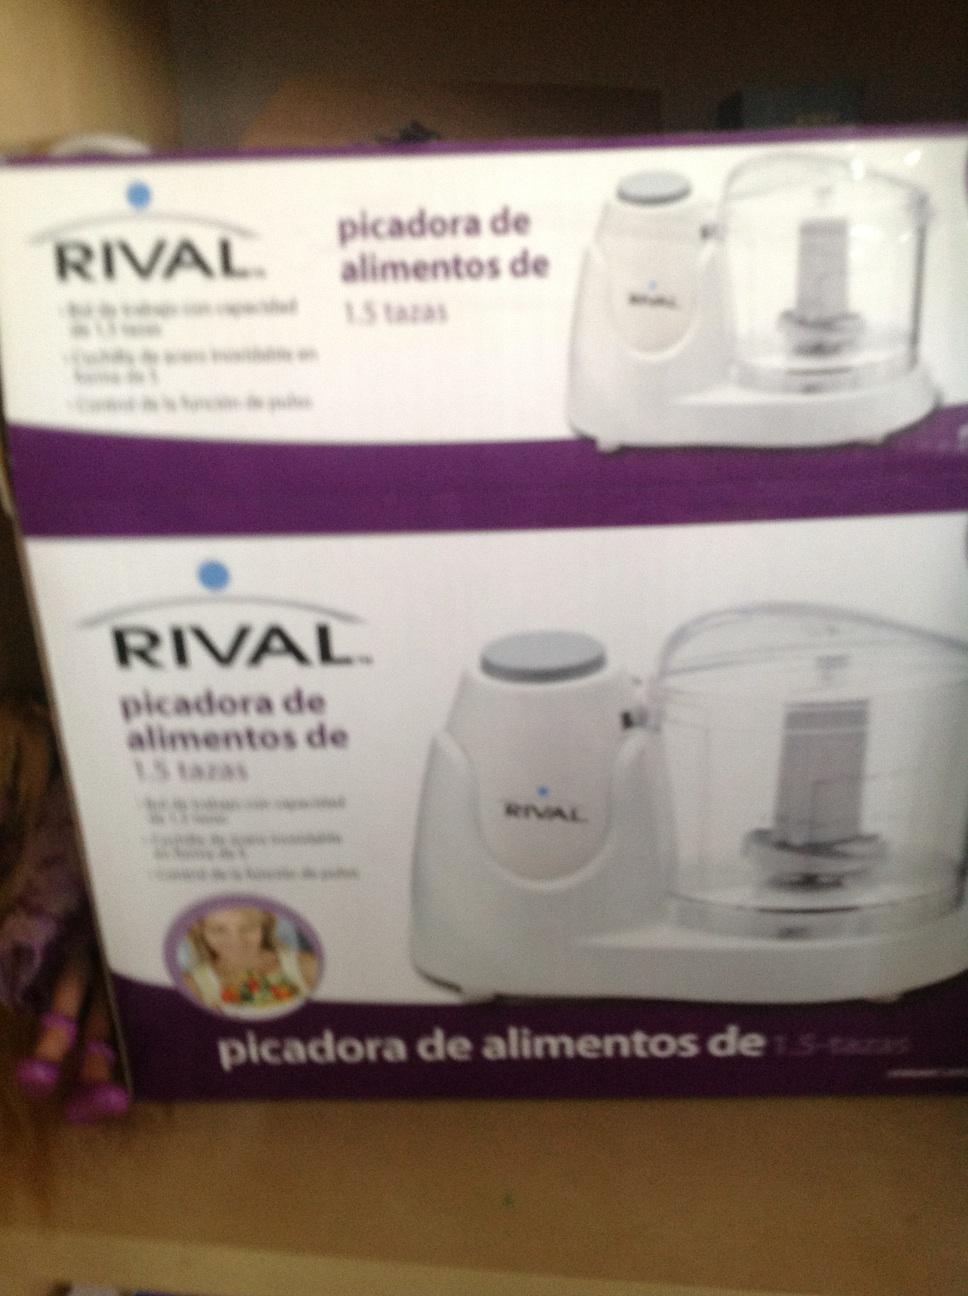What is this? This is a food chopper by the brand RIVAL with a capacity of 1.5 cups. It appears to be packaged in its box, ready for sale. 